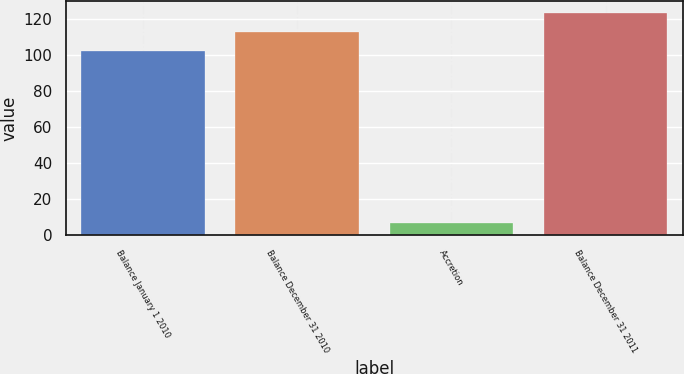Convert chart to OTSL. <chart><loc_0><loc_0><loc_500><loc_500><bar_chart><fcel>Balance January 1 2010<fcel>Balance December 31 2010<fcel>Accretion<fcel>Balance December 31 2011<nl><fcel>102<fcel>112.8<fcel>7<fcel>123.6<nl></chart> 